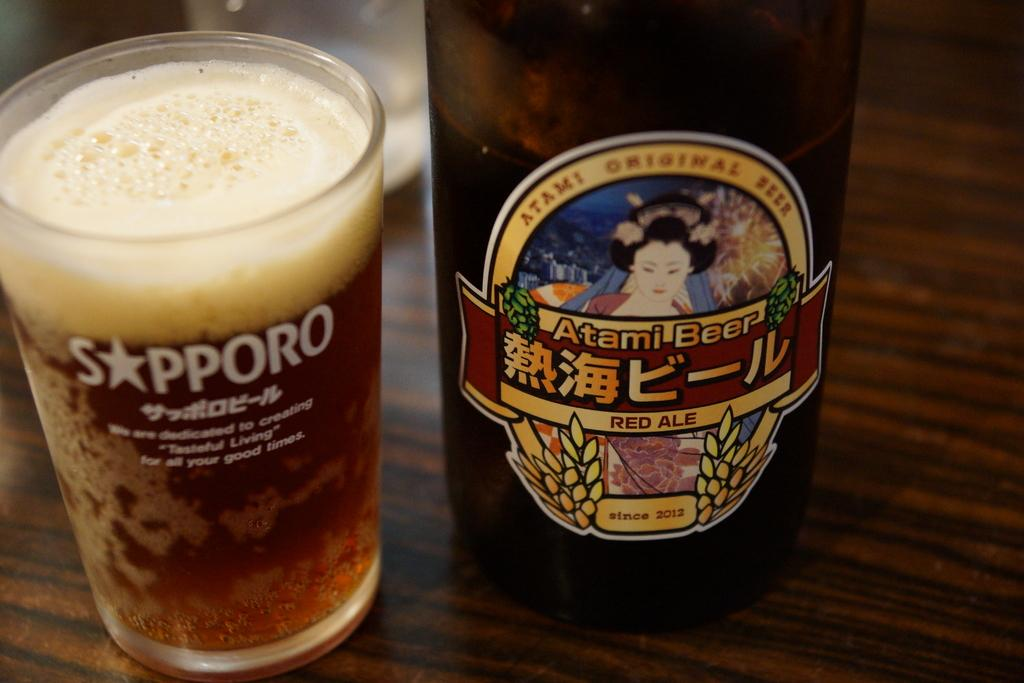<image>
Share a concise interpretation of the image provided. A bottle of Atami Beer is next to a full glass of ale. 